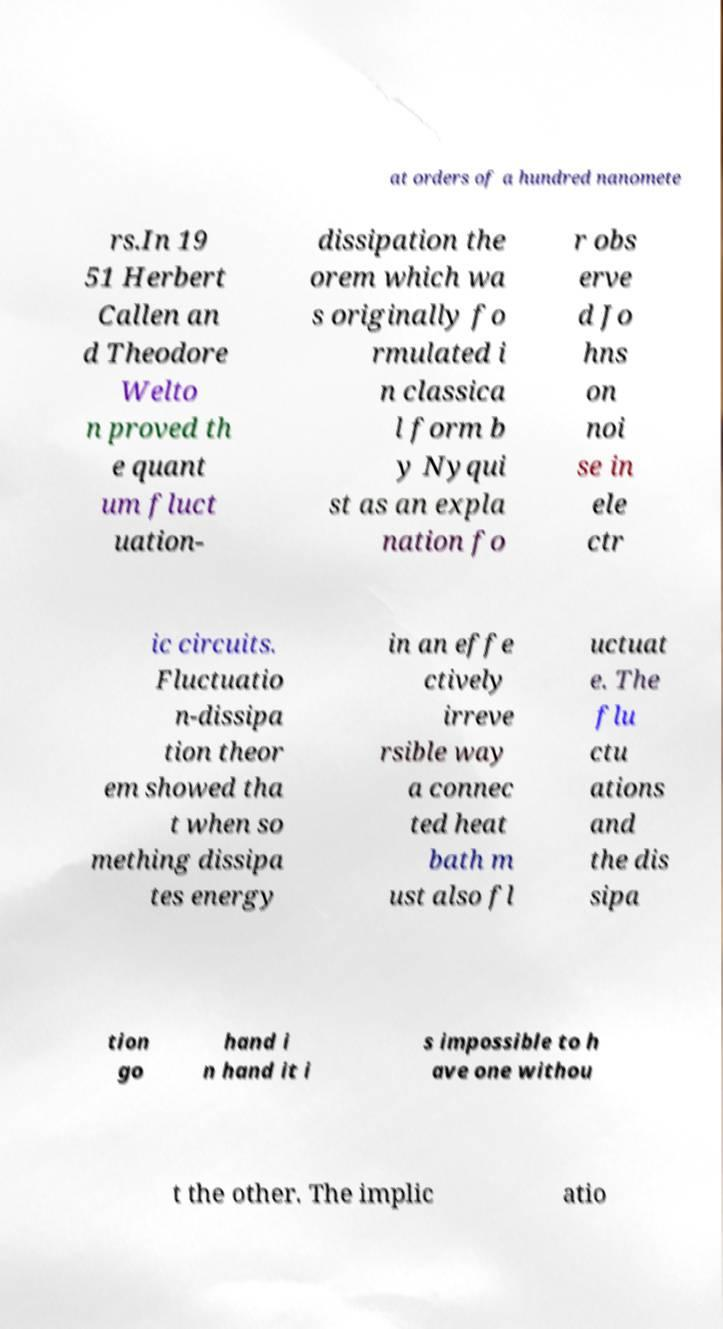Could you assist in decoding the text presented in this image and type it out clearly? at orders of a hundred nanomete rs.In 19 51 Herbert Callen an d Theodore Welto n proved th e quant um fluct uation- dissipation the orem which wa s originally fo rmulated i n classica l form b y Nyqui st as an expla nation fo r obs erve d Jo hns on noi se in ele ctr ic circuits. Fluctuatio n-dissipa tion theor em showed tha t when so mething dissipa tes energy in an effe ctively irreve rsible way a connec ted heat bath m ust also fl uctuat e. The flu ctu ations and the dis sipa tion go hand i n hand it i s impossible to h ave one withou t the other. The implic atio 